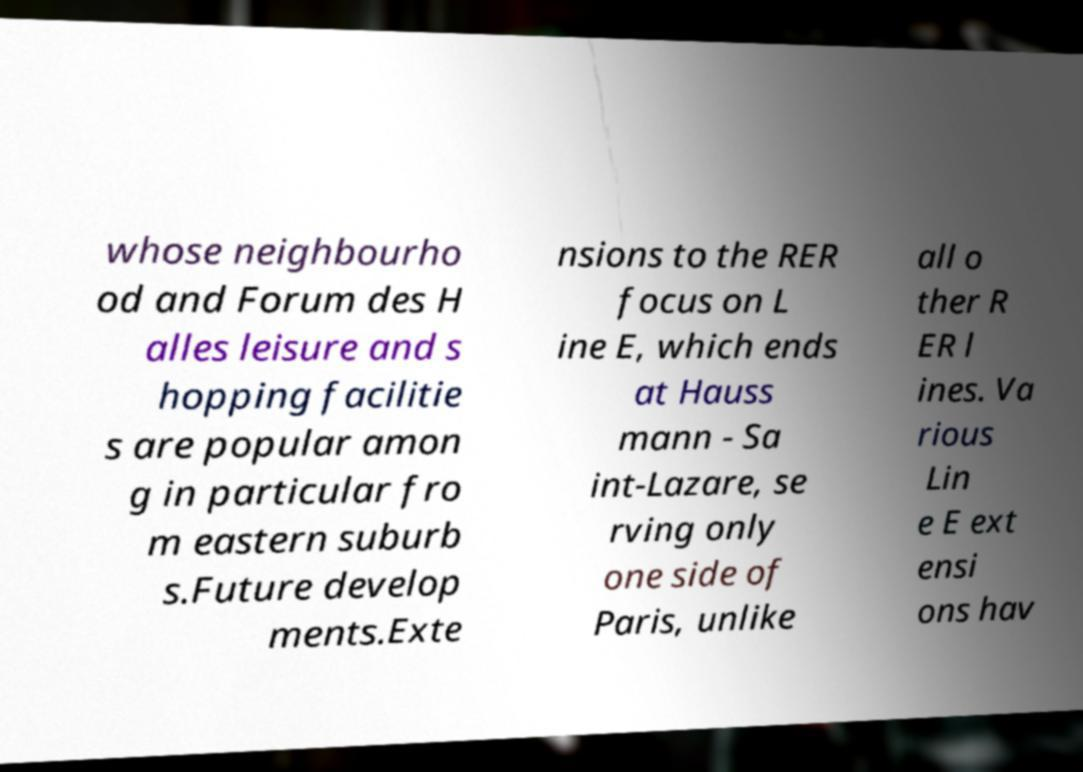Please read and relay the text visible in this image. What does it say? whose neighbourho od and Forum des H alles leisure and s hopping facilitie s are popular amon g in particular fro m eastern suburb s.Future develop ments.Exte nsions to the RER focus on L ine E, which ends at Hauss mann - Sa int-Lazare, se rving only one side of Paris, unlike all o ther R ER l ines. Va rious Lin e E ext ensi ons hav 